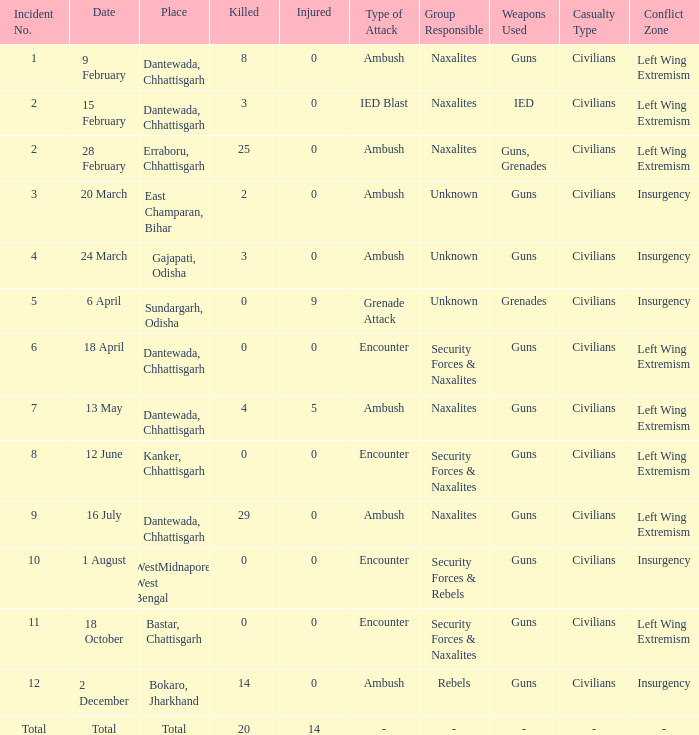How many people were injured in total in East Champaran, Bihar with more than 2 people killed? 0.0. Could you help me parse every detail presented in this table? {'header': ['Incident No.', 'Date', 'Place', 'Killed', 'Injured', 'Type of Attack', 'Group Responsible', 'Weapons Used', 'Casualty Type', 'Conflict Zone'], 'rows': [['1', '9 February', 'Dantewada, Chhattisgarh', '8', '0', 'Ambush', 'Naxalites', 'Guns', 'Civilians', 'Left Wing Extremism'], ['2', '15 February', 'Dantewada, Chhattisgarh', '3', '0', 'IED Blast', 'Naxalites', 'IED', 'Civilians', 'Left Wing Extremism'], ['2', '28 February', 'Erraboru, Chhattisgarh', '25', '0', 'Ambush', 'Naxalites', 'Guns, Grenades', 'Civilians', 'Left Wing Extremism'], ['3', '20 March', 'East Champaran, Bihar', '2', '0', 'Ambush', 'Unknown', 'Guns', 'Civilians', 'Insurgency'], ['4', '24 March', 'Gajapati, Odisha', '3', '0', 'Ambush', 'Unknown', 'Guns', 'Civilians', 'Insurgency'], ['5', '6 April', 'Sundargarh, Odisha', '0', '9', 'Grenade Attack', 'Unknown', 'Grenades', 'Civilians', 'Insurgency'], ['6', '18 April', 'Dantewada, Chhattisgarh', '0', '0', 'Encounter', 'Security Forces & Naxalites', 'Guns', 'Civilians', 'Left Wing Extremism'], ['7', '13 May', 'Dantewada, Chhattisgarh', '4', '5', 'Ambush', 'Naxalites', 'Guns', 'Civilians', 'Left Wing Extremism'], ['8', '12 June', 'Kanker, Chhattisgarh', '0', '0', 'Encounter', 'Security Forces & Naxalites', 'Guns', 'Civilians', 'Left Wing Extremism'], ['9', '16 July', 'Dantewada, Chhattisgarh', '29', '0', 'Ambush', 'Naxalites', 'Guns', 'Civilians', 'Left Wing Extremism'], ['10', '1 August', 'WestMidnapore, West Bengal', '0', '0', 'Encounter', 'Security Forces & Rebels', 'Guns', 'Civilians', 'Insurgency'], ['11', '18 October', 'Bastar, Chattisgarh', '0', '0', 'Encounter', 'Security Forces & Naxalites', 'Guns', 'Civilians', 'Left Wing Extremism'], ['12', '2 December', 'Bokaro, Jharkhand', '14', '0', 'Ambush', 'Rebels', 'Guns', 'Civilians', 'Insurgency'], ['Total', 'Total', 'Total', '20', '14', '-', '-', '-', '-', '-']]} 